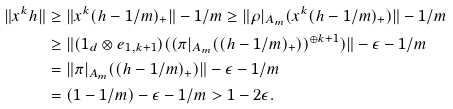Convert formula to latex. <formula><loc_0><loc_0><loc_500><loc_500>\| x ^ { k } h \| & \geq \| x ^ { k } ( h - 1 / m ) _ { + } \| - 1 / m \geq \| \rho | _ { A _ { m } } ( x ^ { k } ( h - 1 / m ) _ { + } ) \| - 1 / m \\ & \geq \| ( 1 _ { d } \otimes e _ { 1 , k + 1 } ) ( ( \pi | _ { A _ { m } } ( ( h - 1 / m ) _ { + } ) ) ^ { \oplus k + 1 } ) \| - \epsilon - 1 / m \\ & = \| \pi | _ { A _ { m } } ( ( h - 1 / m ) _ { + } ) \| - \epsilon - 1 / m \\ & = ( 1 - 1 / m ) - \epsilon - 1 / m > 1 - 2 \epsilon .</formula> 